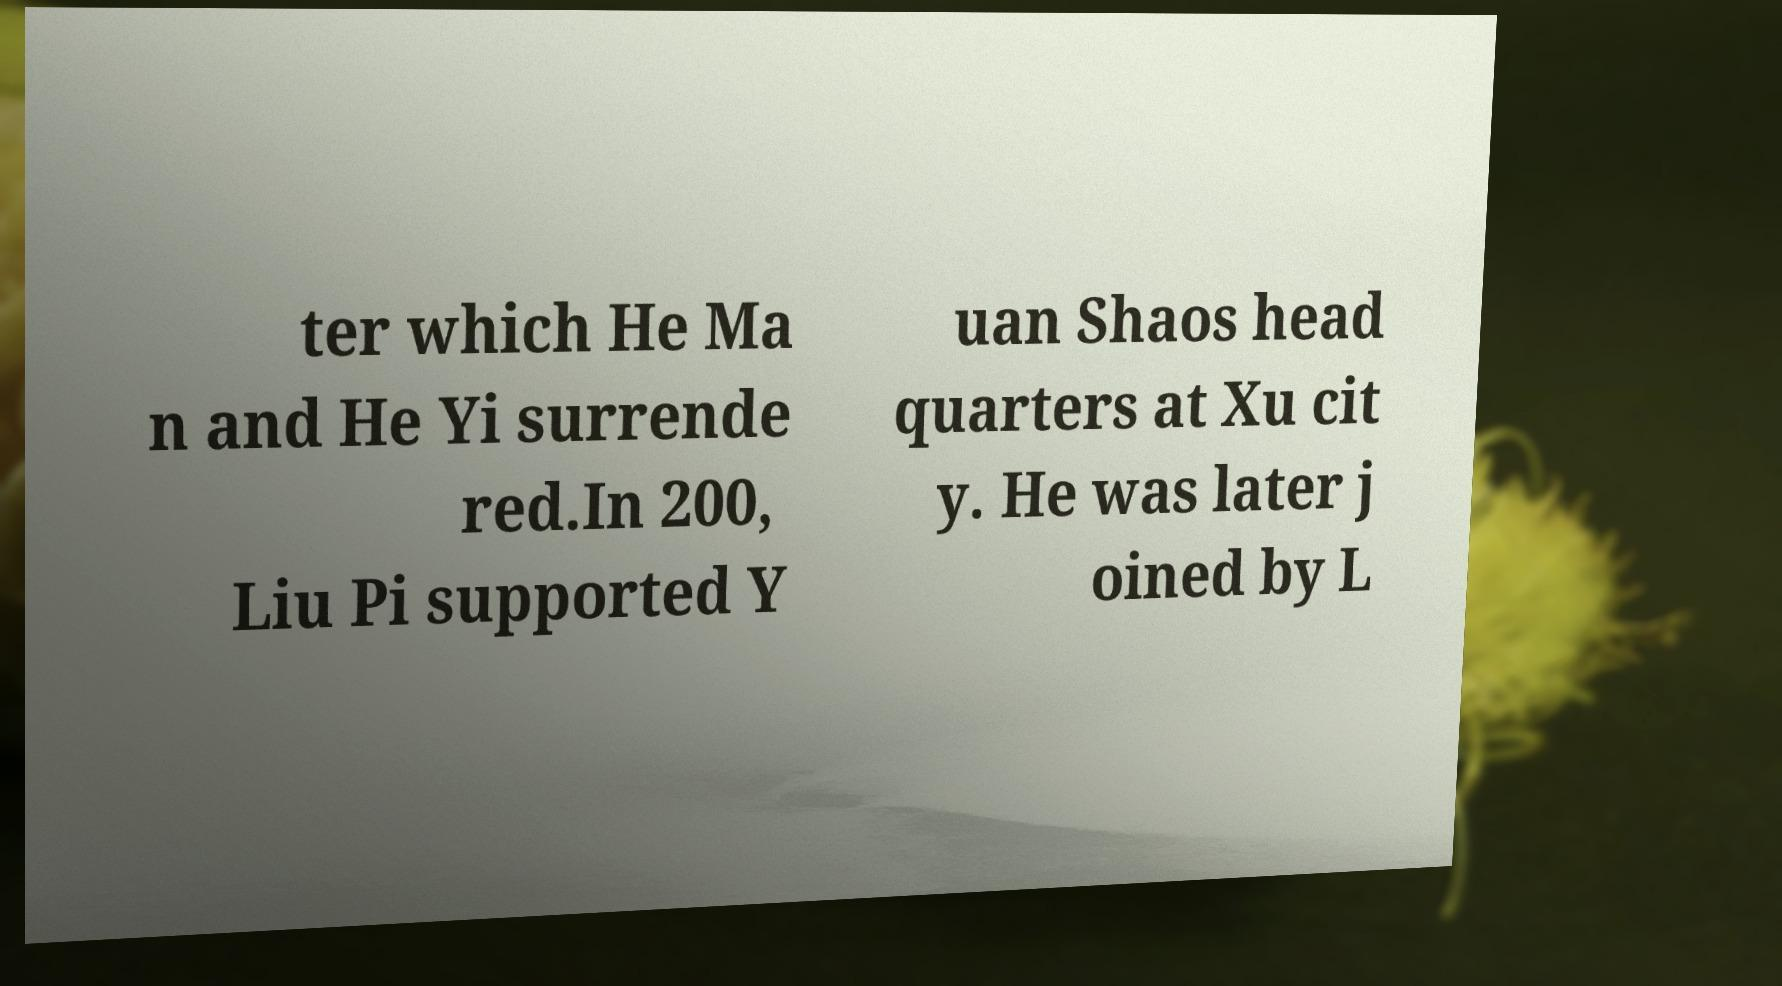Please read and relay the text visible in this image. What does it say? ter which He Ma n and He Yi surrende red.In 200, Liu Pi supported Y uan Shaos head quarters at Xu cit y. He was later j oined by L 